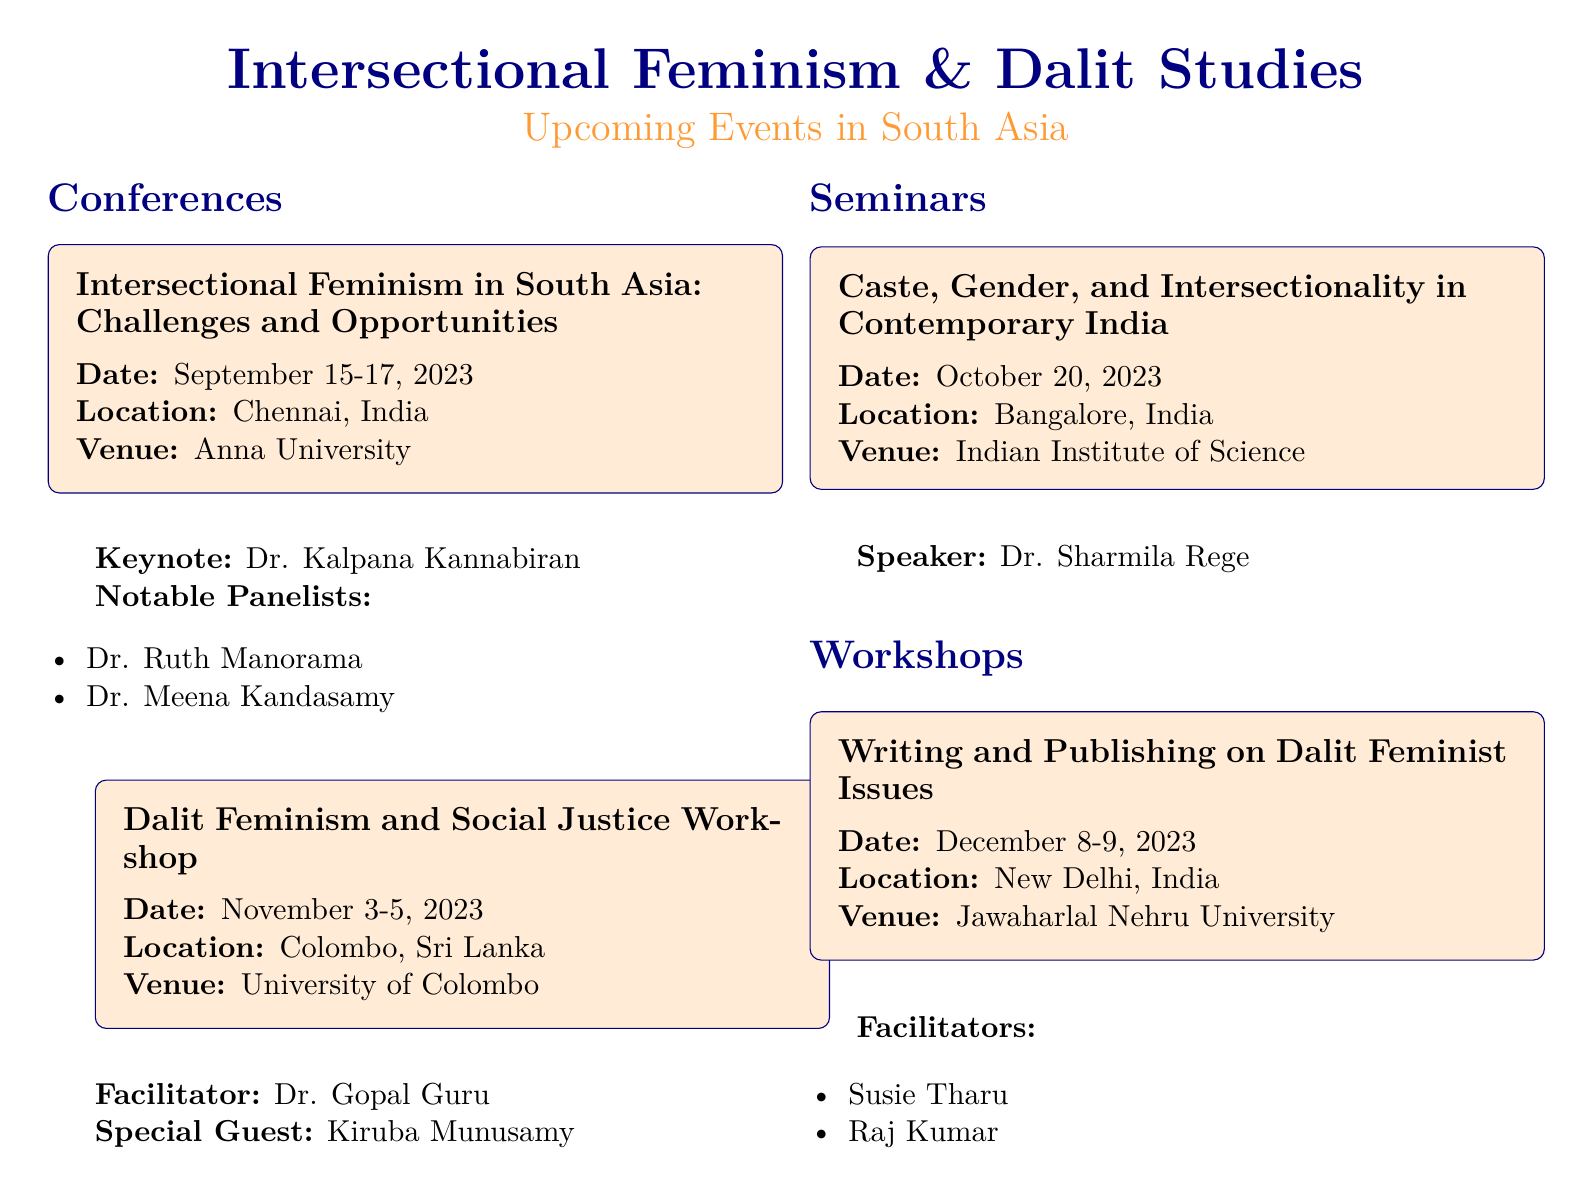What is the date of the Intersectional Feminism in South Asia conference? The date is explicitly mentioned in the event box for the conference, which is September 15-17, 2023.
Answer: September 15-17, 2023 Where will the Dalit Feminism and Social Justice Workshop be held? The venue is specified in the event box, which states it will be at the University of Colombo.
Answer: University of Colombo Who is the keynote speaker for the Intersectional Feminism in South Asia conference? The keynote speaker is listed under the event box, named as Dr. Kalpana Kannabiran.
Answer: Dr. Kalpana Kannabiran What is the date for the Writing and Publishing on Dalit Feminist Issues workshop? This date is clearly outlined in the document under the workshop’s event box, which is December 8-9, 2023.
Answer: December 8-9, 2023 Which speaker will focus on caste, gender, and intersectionality in the seminar? The speaker's name is provided in the seminar's event box as Dr. Sharmila Rege.
Answer: Dr. Sharmila Rege What is the location of the seminar on Caste, Gender, and Intersectionality? The location is given in the event box for the seminar, which shows Bangalore, India.
Answer: Bangalore, India Who are the facilitators for the Writing and Publishing on Dalit Feminist Issues workshop? The facilitators are explicitly listed in the event box, named Susie Tharu and Raj Kumar.
Answer: Susie Tharu, Raj Kumar What type of event is scheduled for October 20, 2023? This date corresponds to a seminar, as indicated in the structure of the document.
Answer: Seminar Which city will host the upcoming Dalit Feminism and Social Justice Workshop? The city is provided in the event box under the workshop's details, identified as Colombo, Sri Lanka.
Answer: Colombo, Sri Lanka 